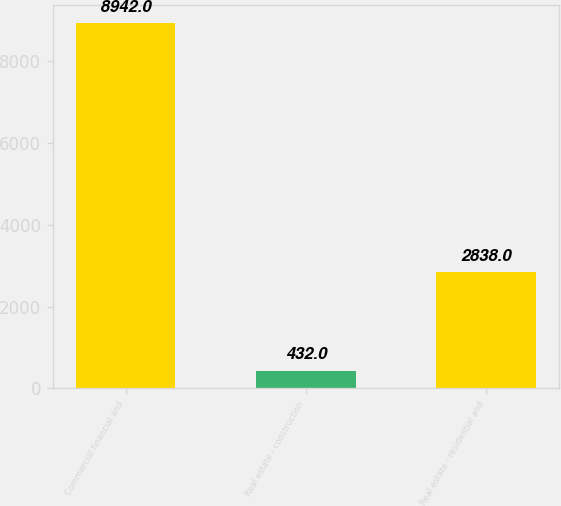<chart> <loc_0><loc_0><loc_500><loc_500><bar_chart><fcel>Commercial financial and<fcel>Real estate - construction<fcel>Real estate - residential and<nl><fcel>8942<fcel>432<fcel>2838<nl></chart> 